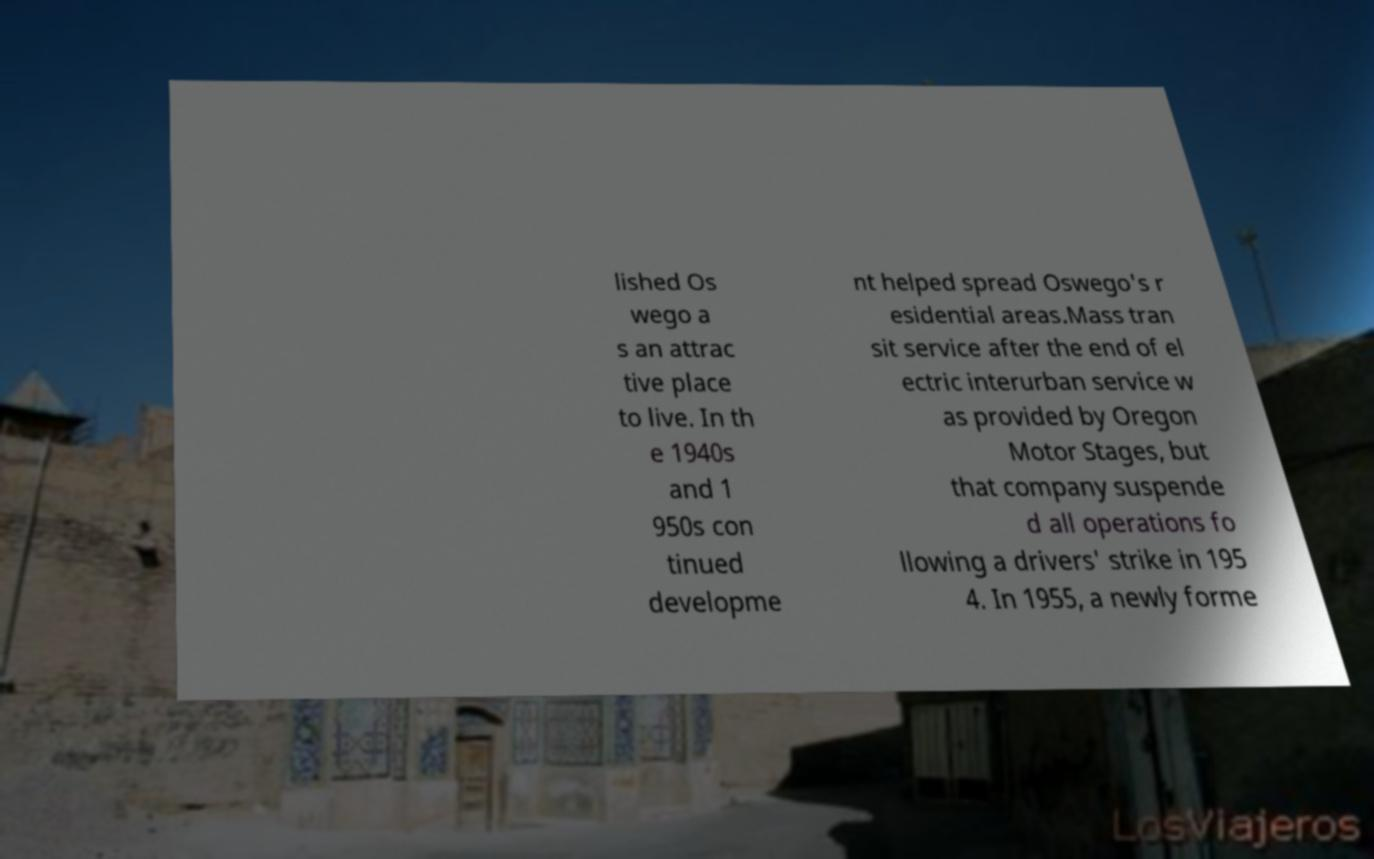Could you extract and type out the text from this image? lished Os wego a s an attrac tive place to live. In th e 1940s and 1 950s con tinued developme nt helped spread Oswego's r esidential areas.Mass tran sit service after the end of el ectric interurban service w as provided by Oregon Motor Stages, but that company suspende d all operations fo llowing a drivers' strike in 195 4. In 1955, a newly forme 